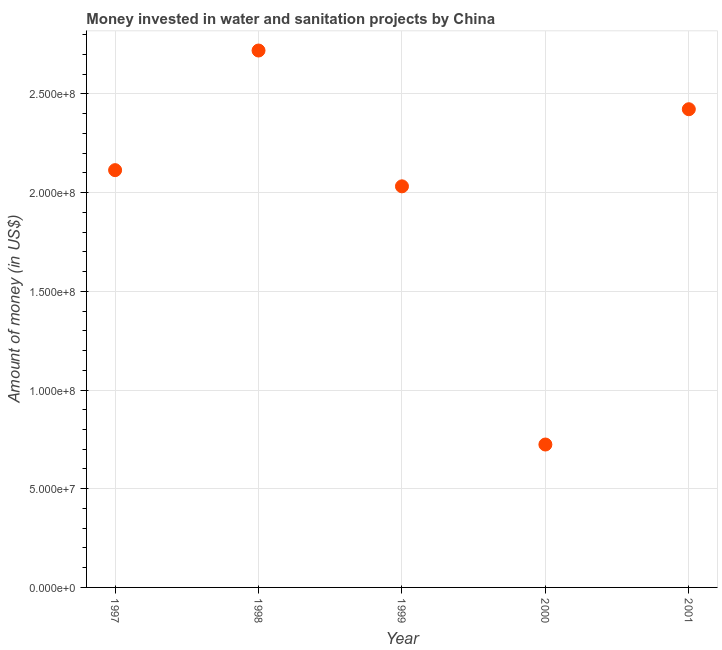What is the investment in 1999?
Your answer should be compact. 2.03e+08. Across all years, what is the maximum investment?
Offer a very short reply. 2.72e+08. Across all years, what is the minimum investment?
Make the answer very short. 7.24e+07. In which year was the investment minimum?
Offer a terse response. 2000. What is the sum of the investment?
Offer a very short reply. 1.00e+09. What is the difference between the investment in 1997 and 1999?
Keep it short and to the point. 8.20e+06. What is the average investment per year?
Your answer should be very brief. 2.00e+08. What is the median investment?
Give a very brief answer. 2.11e+08. What is the ratio of the investment in 1997 to that in 2000?
Your answer should be very brief. 2.92. Is the investment in 1998 less than that in 1999?
Offer a very short reply. No. What is the difference between the highest and the second highest investment?
Provide a short and direct response. 2.97e+07. Is the sum of the investment in 1998 and 2001 greater than the maximum investment across all years?
Offer a very short reply. Yes. What is the difference between the highest and the lowest investment?
Give a very brief answer. 2.00e+08. How many years are there in the graph?
Your response must be concise. 5. What is the difference between two consecutive major ticks on the Y-axis?
Offer a terse response. 5.00e+07. Does the graph contain any zero values?
Make the answer very short. No. What is the title of the graph?
Give a very brief answer. Money invested in water and sanitation projects by China. What is the label or title of the X-axis?
Offer a very short reply. Year. What is the label or title of the Y-axis?
Make the answer very short. Amount of money (in US$). What is the Amount of money (in US$) in 1997?
Your answer should be very brief. 2.11e+08. What is the Amount of money (in US$) in 1998?
Provide a short and direct response. 2.72e+08. What is the Amount of money (in US$) in 1999?
Give a very brief answer. 2.03e+08. What is the Amount of money (in US$) in 2000?
Your answer should be compact. 7.24e+07. What is the Amount of money (in US$) in 2001?
Offer a terse response. 2.42e+08. What is the difference between the Amount of money (in US$) in 1997 and 1998?
Provide a short and direct response. -6.06e+07. What is the difference between the Amount of money (in US$) in 1997 and 1999?
Your answer should be compact. 8.20e+06. What is the difference between the Amount of money (in US$) in 1997 and 2000?
Make the answer very short. 1.39e+08. What is the difference between the Amount of money (in US$) in 1997 and 2001?
Give a very brief answer. -3.09e+07. What is the difference between the Amount of money (in US$) in 1998 and 1999?
Your answer should be very brief. 6.88e+07. What is the difference between the Amount of money (in US$) in 1998 and 2000?
Ensure brevity in your answer.  2.00e+08. What is the difference between the Amount of money (in US$) in 1998 and 2001?
Provide a succinct answer. 2.97e+07. What is the difference between the Amount of money (in US$) in 1999 and 2000?
Your answer should be very brief. 1.31e+08. What is the difference between the Amount of money (in US$) in 1999 and 2001?
Provide a short and direct response. -3.91e+07. What is the difference between the Amount of money (in US$) in 2000 and 2001?
Give a very brief answer. -1.70e+08. What is the ratio of the Amount of money (in US$) in 1997 to that in 1998?
Make the answer very short. 0.78. What is the ratio of the Amount of money (in US$) in 1997 to that in 1999?
Your response must be concise. 1.04. What is the ratio of the Amount of money (in US$) in 1997 to that in 2000?
Your answer should be very brief. 2.92. What is the ratio of the Amount of money (in US$) in 1997 to that in 2001?
Keep it short and to the point. 0.87. What is the ratio of the Amount of money (in US$) in 1998 to that in 1999?
Your answer should be very brief. 1.34. What is the ratio of the Amount of money (in US$) in 1998 to that in 2000?
Ensure brevity in your answer.  3.76. What is the ratio of the Amount of money (in US$) in 1998 to that in 2001?
Offer a terse response. 1.12. What is the ratio of the Amount of money (in US$) in 1999 to that in 2000?
Offer a terse response. 2.81. What is the ratio of the Amount of money (in US$) in 1999 to that in 2001?
Keep it short and to the point. 0.84. What is the ratio of the Amount of money (in US$) in 2000 to that in 2001?
Keep it short and to the point. 0.3. 